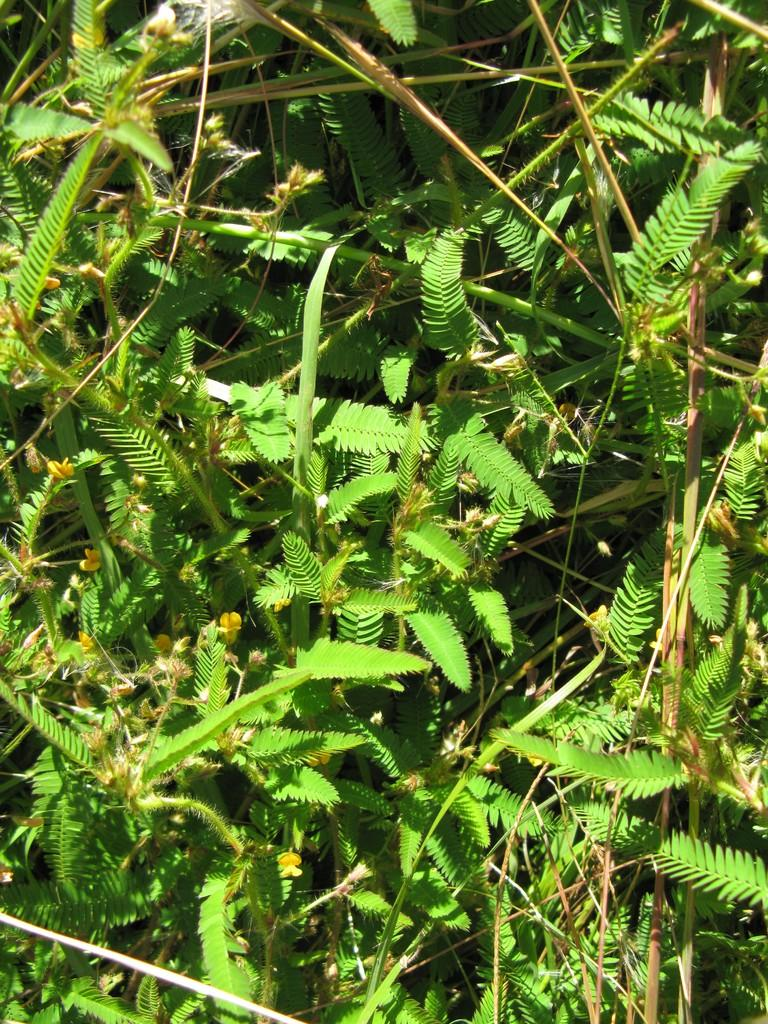What type of plant is featured in the image? The image contains leaves of a touch-me-not plant. Can you see a team of rabbits playing with a ball in the image? There is no team of rabbits or ball present in the image; it features leaves of a touch-me-not plant. 